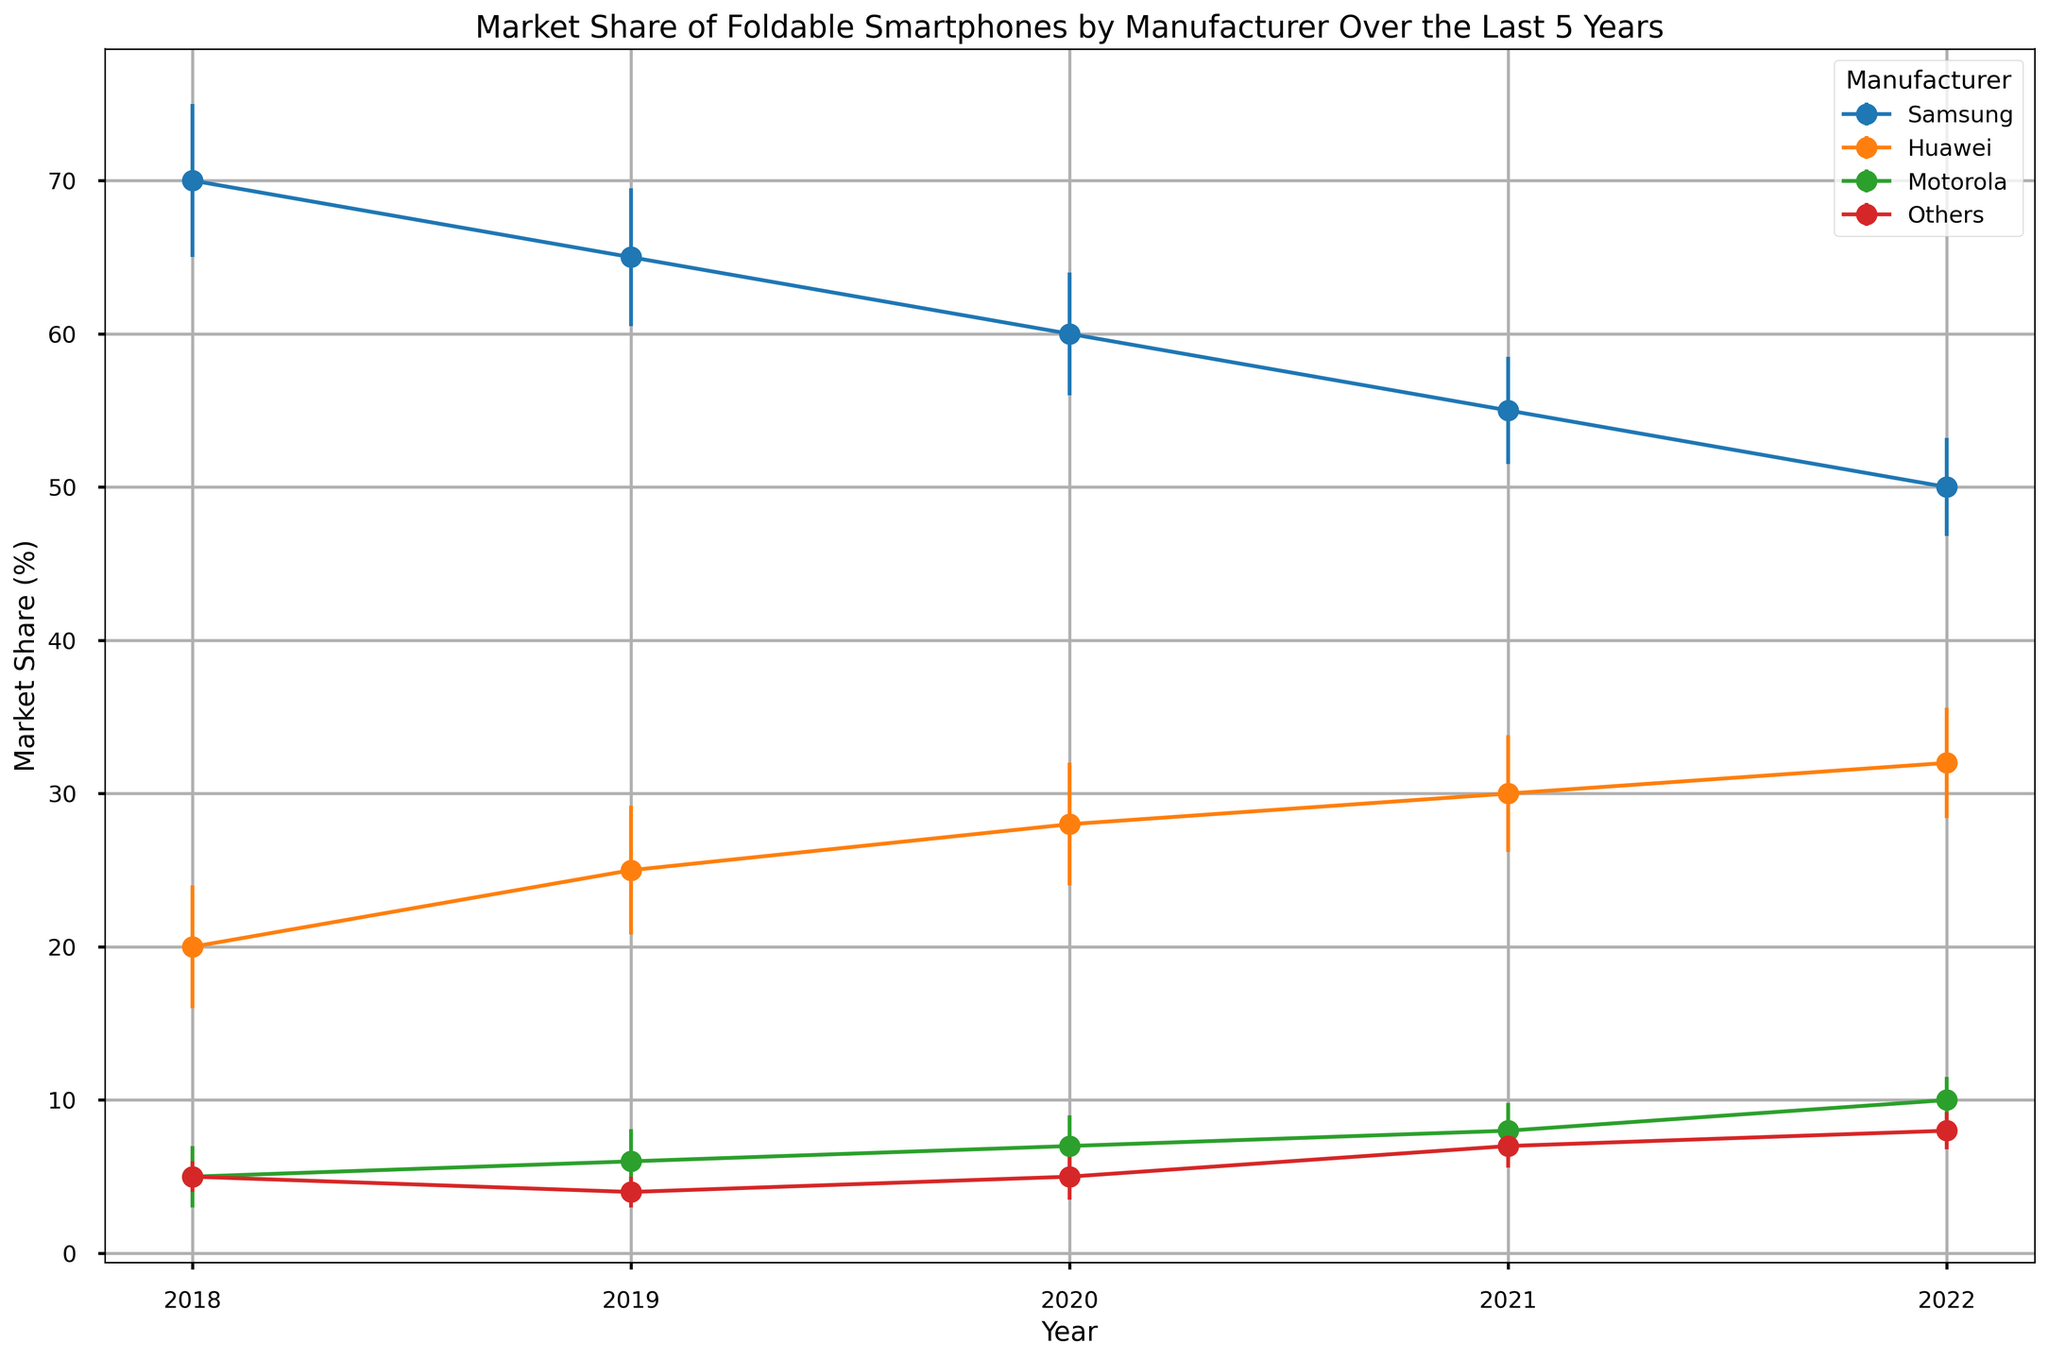Which manufacturer had the highest market share in 2022? Look at the market share (%) for each manufacturer in 2022 and identify the highest value. Samsung has 50%, Huawei has 32%, Motorola has 10%, and Others have 8%. Therefore, Samsung had the highest market share.
Answer: Samsung How did Samsung's market share change from 2018 to 2022? Compare Samsung's market share in 2018 (70%) to that in 2022 (50%). Calculate the difference: 70% - 50% = 20%.
Answer: Decreased by 20% What is the overall trend for Huawei's market share from 2018 to 2022? Examine the market share values for Huawei over the five years: 20% in 2018, 25% in 2019, 28% in 2020, 30% in 2021, and 32% in 2022. Observe the general direction of these values over time. They increase every year.
Answer: Increasing trend Compare the confidence intervals for Motorola in 2018 and 2022. How did they change? The confidence interval for Motorola in 2018 is ±2%, and in 2022 it is ±1.5%. Compare these values: 2% - 1.5% = 0.5%. The confidence interval decreased by 0.5%.
Answer: Decreased by 0.5% What was the average market share of Samsung over the 5 years? Sum the market shares of Samsung from each year (70% + 65% + 60% + 55% + 50%) = 300%. Divide by the number of years (5): 300% / 5 = 60%.
Answer: 60% Among all manufacturers, which one had the smallest error bar in 2022? Compare the confidence intervals for each manufacturer in 2022: Samsung (±3.2%), Huawei (±3.6%), Motorola (±1.5%), and Others (±1.2%). The 'Others' category has the smallest error bar.
Answer: Others 